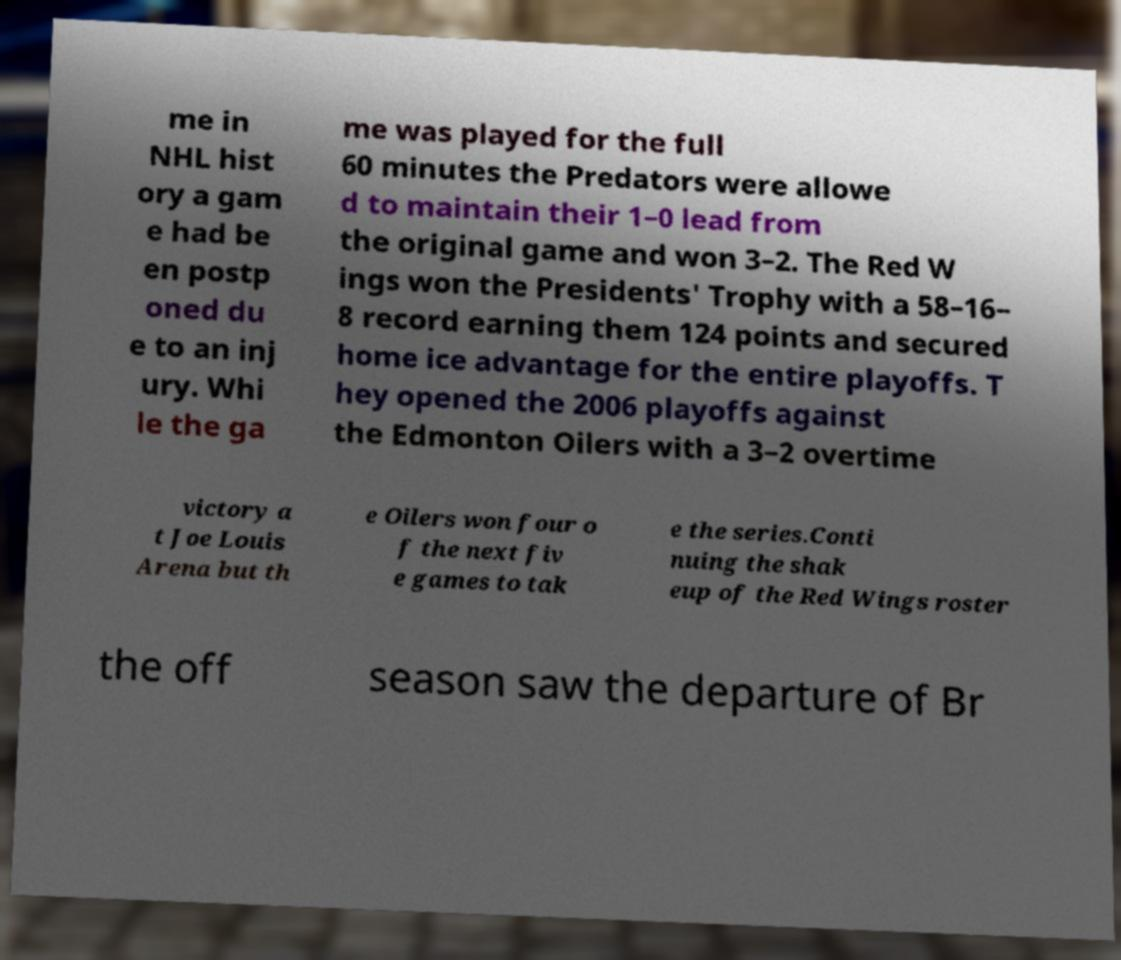Could you extract and type out the text from this image? me in NHL hist ory a gam e had be en postp oned du e to an inj ury. Whi le the ga me was played for the full 60 minutes the Predators were allowe d to maintain their 1–0 lead from the original game and won 3–2. The Red W ings won the Presidents' Trophy with a 58–16– 8 record earning them 124 points and secured home ice advantage for the entire playoffs. T hey opened the 2006 playoffs against the Edmonton Oilers with a 3–2 overtime victory a t Joe Louis Arena but th e Oilers won four o f the next fiv e games to tak e the series.Conti nuing the shak eup of the Red Wings roster the off season saw the departure of Br 